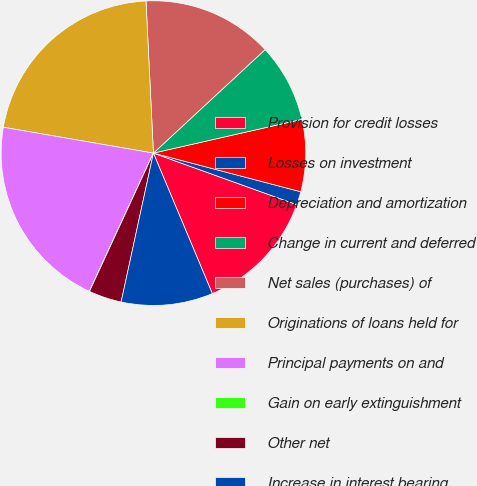Convert chart to OTSL. <chart><loc_0><loc_0><loc_500><loc_500><pie_chart><fcel>Provision for credit losses<fcel>Losses on investment<fcel>Depreciation and amortization<fcel>Change in current and deferred<fcel>Net sales (purchases) of<fcel>Originations of loans held for<fcel>Principal payments on and<fcel>Gain on early extinguishment<fcel>Other net<fcel>Increase in interest bearing<nl><fcel>13.19%<fcel>1.41%<fcel>7.64%<fcel>8.34%<fcel>13.88%<fcel>21.51%<fcel>20.81%<fcel>0.02%<fcel>3.49%<fcel>9.72%<nl></chart> 